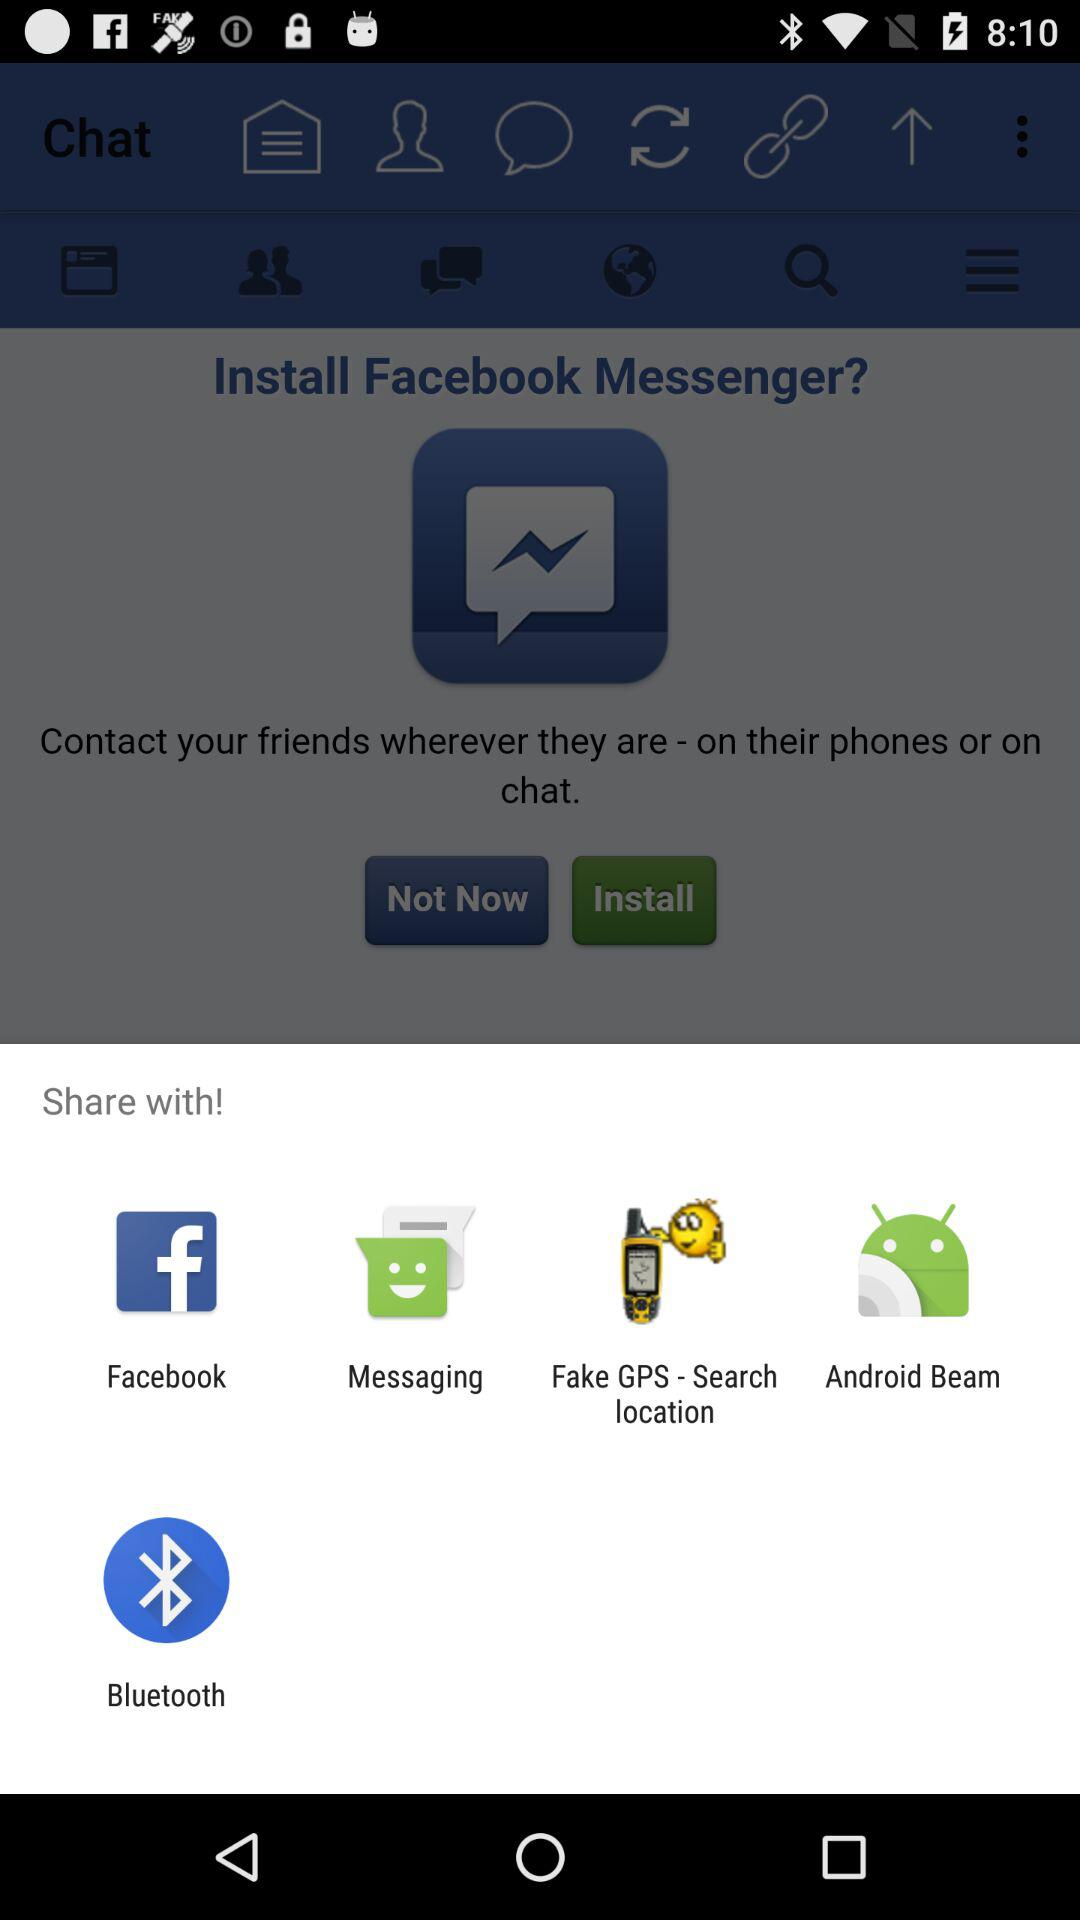Which are the different sharing options? The different sharing options are "Facebook", "Messaging", "Fake GPS - Search location", "Android Beam" and "Bluetooth". 